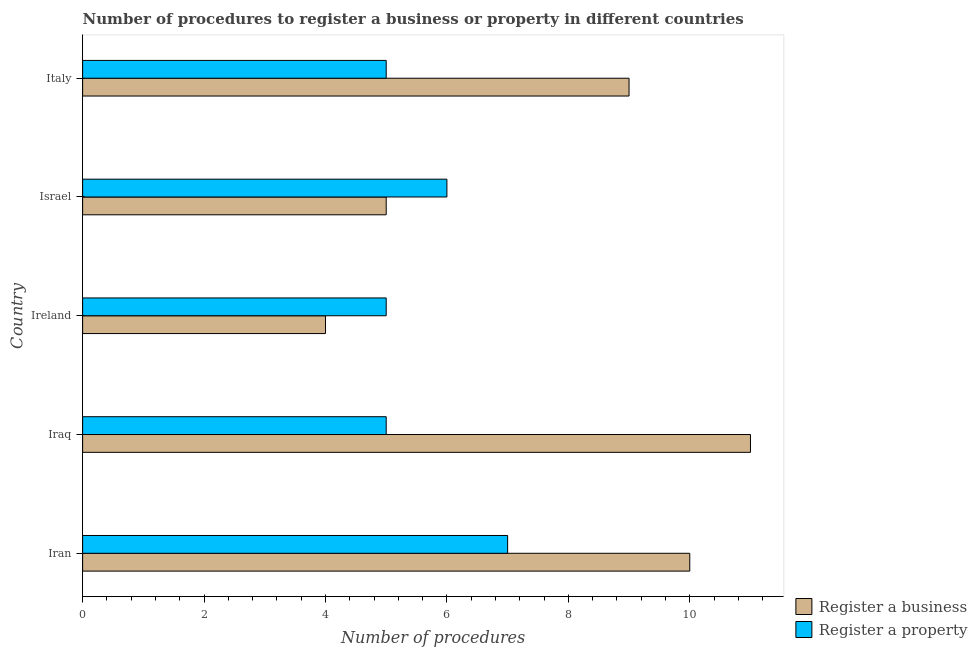How many different coloured bars are there?
Offer a very short reply. 2. Are the number of bars per tick equal to the number of legend labels?
Keep it short and to the point. Yes. How many bars are there on the 1st tick from the bottom?
Give a very brief answer. 2. What is the label of the 4th group of bars from the top?
Provide a succinct answer. Iraq. What is the number of procedures to register a business in Israel?
Offer a very short reply. 5. Across all countries, what is the minimum number of procedures to register a business?
Offer a terse response. 4. In which country was the number of procedures to register a business maximum?
Make the answer very short. Iraq. In which country was the number of procedures to register a property minimum?
Your answer should be compact. Iraq. What is the difference between the number of procedures to register a property in Israel and the number of procedures to register a business in Ireland?
Keep it short and to the point. 2. What is the average number of procedures to register a property per country?
Your answer should be very brief. 5.6. What is the difference between the number of procedures to register a property and number of procedures to register a business in Iraq?
Your answer should be compact. -6. What is the ratio of the number of procedures to register a property in Ireland to that in Italy?
Offer a very short reply. 1. Is the difference between the number of procedures to register a property in Iraq and Israel greater than the difference between the number of procedures to register a business in Iraq and Israel?
Provide a short and direct response. No. In how many countries, is the number of procedures to register a property greater than the average number of procedures to register a property taken over all countries?
Provide a short and direct response. 2. Is the sum of the number of procedures to register a property in Iraq and Ireland greater than the maximum number of procedures to register a business across all countries?
Your answer should be very brief. No. What does the 2nd bar from the top in Italy represents?
Keep it short and to the point. Register a business. What does the 1st bar from the bottom in Italy represents?
Give a very brief answer. Register a business. What is the difference between two consecutive major ticks on the X-axis?
Offer a terse response. 2. Does the graph contain grids?
Offer a terse response. No. Where does the legend appear in the graph?
Provide a short and direct response. Bottom right. How many legend labels are there?
Your response must be concise. 2. How are the legend labels stacked?
Offer a very short reply. Vertical. What is the title of the graph?
Keep it short and to the point. Number of procedures to register a business or property in different countries. What is the label or title of the X-axis?
Provide a succinct answer. Number of procedures. What is the Number of procedures of Register a business in Iran?
Your answer should be compact. 10. What is the Number of procedures of Register a business in Iraq?
Provide a succinct answer. 11. What is the Number of procedures of Register a business in Ireland?
Keep it short and to the point. 4. What is the Number of procedures in Register a property in Ireland?
Ensure brevity in your answer.  5. What is the Number of procedures of Register a business in Israel?
Keep it short and to the point. 5. What is the Number of procedures of Register a property in Israel?
Ensure brevity in your answer.  6. What is the Number of procedures of Register a property in Italy?
Keep it short and to the point. 5. Across all countries, what is the maximum Number of procedures of Register a business?
Your answer should be very brief. 11. Across all countries, what is the minimum Number of procedures of Register a business?
Your response must be concise. 4. Across all countries, what is the minimum Number of procedures of Register a property?
Ensure brevity in your answer.  5. What is the total Number of procedures in Register a business in the graph?
Offer a terse response. 39. What is the total Number of procedures of Register a property in the graph?
Ensure brevity in your answer.  28. What is the difference between the Number of procedures of Register a business in Iran and that in Iraq?
Ensure brevity in your answer.  -1. What is the difference between the Number of procedures of Register a property in Iran and that in Ireland?
Ensure brevity in your answer.  2. What is the difference between the Number of procedures of Register a property in Iran and that in Israel?
Make the answer very short. 1. What is the difference between the Number of procedures in Register a business in Ireland and that in Israel?
Offer a very short reply. -1. What is the difference between the Number of procedures in Register a property in Ireland and that in Italy?
Make the answer very short. 0. What is the difference between the Number of procedures in Register a property in Israel and that in Italy?
Offer a very short reply. 1. What is the difference between the Number of procedures of Register a business in Iran and the Number of procedures of Register a property in Iraq?
Your response must be concise. 5. What is the difference between the Number of procedures in Register a business in Iran and the Number of procedures in Register a property in Italy?
Ensure brevity in your answer.  5. What is the difference between the Number of procedures of Register a business in Iraq and the Number of procedures of Register a property in Ireland?
Your answer should be compact. 6. What is the difference between the Number of procedures in Register a business in Ireland and the Number of procedures in Register a property in Italy?
Give a very brief answer. -1. What is the difference between the Number of procedures in Register a business and Number of procedures in Register a property in Iran?
Make the answer very short. 3. What is the difference between the Number of procedures in Register a business and Number of procedures in Register a property in Italy?
Offer a very short reply. 4. What is the ratio of the Number of procedures of Register a business in Iran to that in Ireland?
Offer a very short reply. 2.5. What is the ratio of the Number of procedures of Register a business in Iraq to that in Ireland?
Your answer should be very brief. 2.75. What is the ratio of the Number of procedures of Register a business in Iraq to that in Israel?
Make the answer very short. 2.2. What is the ratio of the Number of procedures of Register a business in Iraq to that in Italy?
Offer a terse response. 1.22. What is the ratio of the Number of procedures of Register a property in Iraq to that in Italy?
Your answer should be very brief. 1. What is the ratio of the Number of procedures of Register a property in Ireland to that in Israel?
Keep it short and to the point. 0.83. What is the ratio of the Number of procedures in Register a business in Ireland to that in Italy?
Keep it short and to the point. 0.44. What is the ratio of the Number of procedures of Register a business in Israel to that in Italy?
Your response must be concise. 0.56. What is the difference between the highest and the second highest Number of procedures of Register a business?
Make the answer very short. 1. What is the difference between the highest and the second highest Number of procedures of Register a property?
Offer a terse response. 1. 